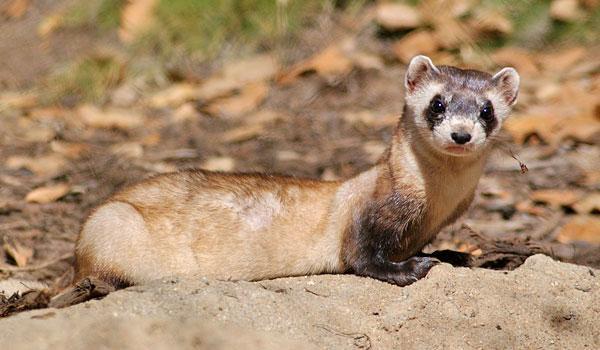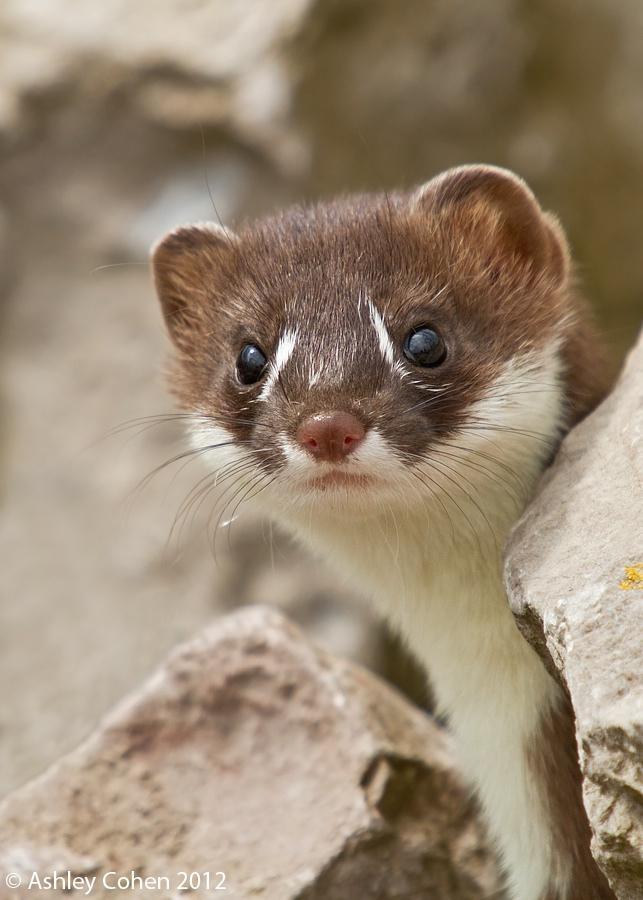The first image is the image on the left, the second image is the image on the right. Examine the images to the left and right. Is the description "There are two black footed ferrets standing in the dirt in the center of the images." accurate? Answer yes or no. No. The first image is the image on the left, the second image is the image on the right. Considering the images on both sides, is "In one image of each pair an animal is looking towards (the image viewers) left." valid? Answer yes or no. No. 